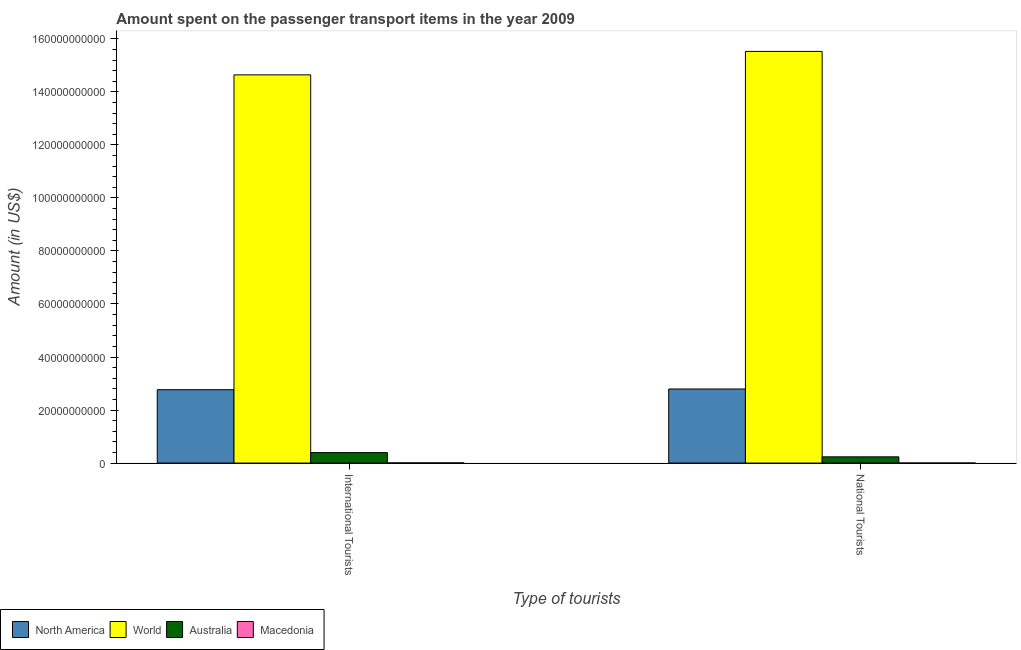How many groups of bars are there?
Your response must be concise. 2. Are the number of bars on each tick of the X-axis equal?
Your answer should be compact. Yes. How many bars are there on the 2nd tick from the left?
Your answer should be compact. 4. How many bars are there on the 2nd tick from the right?
Ensure brevity in your answer.  4. What is the label of the 1st group of bars from the left?
Offer a terse response. International Tourists. What is the amount spent on transport items of national tourists in Australia?
Make the answer very short. 2.34e+09. Across all countries, what is the maximum amount spent on transport items of national tourists?
Give a very brief answer. 1.55e+11. Across all countries, what is the minimum amount spent on transport items of international tourists?
Provide a short and direct response. 5.00e+07. In which country was the amount spent on transport items of international tourists maximum?
Your answer should be compact. World. In which country was the amount spent on transport items of national tourists minimum?
Your answer should be very brief. Macedonia. What is the total amount spent on transport items of international tourists in the graph?
Offer a very short reply. 1.78e+11. What is the difference between the amount spent on transport items of national tourists in World and that in Australia?
Your answer should be compact. 1.53e+11. What is the difference between the amount spent on transport items of international tourists in North America and the amount spent on transport items of national tourists in Macedonia?
Offer a terse response. 2.77e+1. What is the average amount spent on transport items of international tourists per country?
Your answer should be compact. 4.45e+1. What is the difference between the amount spent on transport items of international tourists and amount spent on transport items of national tourists in North America?
Your answer should be very brief. -2.67e+08. What is the ratio of the amount spent on transport items of international tourists in Australia to that in North America?
Offer a terse response. 0.14. In how many countries, is the amount spent on transport items of international tourists greater than the average amount spent on transport items of international tourists taken over all countries?
Provide a succinct answer. 1. What does the 2nd bar from the left in National Tourists represents?
Provide a short and direct response. World. What does the 1st bar from the right in International Tourists represents?
Your answer should be very brief. Macedonia. How many countries are there in the graph?
Give a very brief answer. 4. Does the graph contain any zero values?
Your answer should be very brief. No. Does the graph contain grids?
Offer a very short reply. No. Where does the legend appear in the graph?
Offer a very short reply. Bottom left. How many legend labels are there?
Offer a terse response. 4. How are the legend labels stacked?
Offer a terse response. Horizontal. What is the title of the graph?
Your answer should be compact. Amount spent on the passenger transport items in the year 2009. What is the label or title of the X-axis?
Your answer should be compact. Type of tourists. What is the label or title of the Y-axis?
Make the answer very short. Amount (in US$). What is the Amount (in US$) in North America in International Tourists?
Your answer should be very brief. 2.77e+1. What is the Amount (in US$) in World in International Tourists?
Offer a very short reply. 1.46e+11. What is the Amount (in US$) of Australia in International Tourists?
Your answer should be compact. 3.94e+09. What is the Amount (in US$) in Macedonia in International Tourists?
Ensure brevity in your answer.  5.00e+07. What is the Amount (in US$) in North America in National Tourists?
Your answer should be compact. 2.79e+1. What is the Amount (in US$) of World in National Tourists?
Give a very brief answer. 1.55e+11. What is the Amount (in US$) in Australia in National Tourists?
Make the answer very short. 2.34e+09. What is the Amount (in US$) of Macedonia in National Tourists?
Ensure brevity in your answer.  1.40e+07. Across all Type of tourists, what is the maximum Amount (in US$) of North America?
Your answer should be compact. 2.79e+1. Across all Type of tourists, what is the maximum Amount (in US$) in World?
Offer a very short reply. 1.55e+11. Across all Type of tourists, what is the maximum Amount (in US$) in Australia?
Offer a very short reply. 3.94e+09. Across all Type of tourists, what is the minimum Amount (in US$) of North America?
Offer a terse response. 2.77e+1. Across all Type of tourists, what is the minimum Amount (in US$) of World?
Your response must be concise. 1.46e+11. Across all Type of tourists, what is the minimum Amount (in US$) of Australia?
Your answer should be very brief. 2.34e+09. Across all Type of tourists, what is the minimum Amount (in US$) of Macedonia?
Make the answer very short. 1.40e+07. What is the total Amount (in US$) of North America in the graph?
Provide a short and direct response. 5.56e+1. What is the total Amount (in US$) in World in the graph?
Offer a very short reply. 3.02e+11. What is the total Amount (in US$) in Australia in the graph?
Provide a short and direct response. 6.28e+09. What is the total Amount (in US$) of Macedonia in the graph?
Offer a very short reply. 6.40e+07. What is the difference between the Amount (in US$) in North America in International Tourists and that in National Tourists?
Give a very brief answer. -2.67e+08. What is the difference between the Amount (in US$) of World in International Tourists and that in National Tourists?
Your answer should be very brief. -8.85e+09. What is the difference between the Amount (in US$) in Australia in International Tourists and that in National Tourists?
Your answer should be very brief. 1.60e+09. What is the difference between the Amount (in US$) of Macedonia in International Tourists and that in National Tourists?
Provide a succinct answer. 3.60e+07. What is the difference between the Amount (in US$) of North America in International Tourists and the Amount (in US$) of World in National Tourists?
Your answer should be compact. -1.28e+11. What is the difference between the Amount (in US$) in North America in International Tourists and the Amount (in US$) in Australia in National Tourists?
Ensure brevity in your answer.  2.53e+1. What is the difference between the Amount (in US$) of North America in International Tourists and the Amount (in US$) of Macedonia in National Tourists?
Keep it short and to the point. 2.77e+1. What is the difference between the Amount (in US$) in World in International Tourists and the Amount (in US$) in Australia in National Tourists?
Ensure brevity in your answer.  1.44e+11. What is the difference between the Amount (in US$) of World in International Tourists and the Amount (in US$) of Macedonia in National Tourists?
Offer a terse response. 1.46e+11. What is the difference between the Amount (in US$) in Australia in International Tourists and the Amount (in US$) in Macedonia in National Tourists?
Ensure brevity in your answer.  3.93e+09. What is the average Amount (in US$) in North America per Type of tourists?
Ensure brevity in your answer.  2.78e+1. What is the average Amount (in US$) in World per Type of tourists?
Your answer should be compact. 1.51e+11. What is the average Amount (in US$) in Australia per Type of tourists?
Your answer should be compact. 3.14e+09. What is the average Amount (in US$) of Macedonia per Type of tourists?
Offer a very short reply. 3.20e+07. What is the difference between the Amount (in US$) in North America and Amount (in US$) in World in International Tourists?
Provide a short and direct response. -1.19e+11. What is the difference between the Amount (in US$) of North America and Amount (in US$) of Australia in International Tourists?
Your answer should be very brief. 2.37e+1. What is the difference between the Amount (in US$) of North America and Amount (in US$) of Macedonia in International Tourists?
Offer a very short reply. 2.76e+1. What is the difference between the Amount (in US$) in World and Amount (in US$) in Australia in International Tourists?
Your answer should be very brief. 1.42e+11. What is the difference between the Amount (in US$) of World and Amount (in US$) of Macedonia in International Tourists?
Your answer should be very brief. 1.46e+11. What is the difference between the Amount (in US$) in Australia and Amount (in US$) in Macedonia in International Tourists?
Ensure brevity in your answer.  3.89e+09. What is the difference between the Amount (in US$) in North America and Amount (in US$) in World in National Tourists?
Your answer should be compact. -1.27e+11. What is the difference between the Amount (in US$) in North America and Amount (in US$) in Australia in National Tourists?
Provide a short and direct response. 2.56e+1. What is the difference between the Amount (in US$) of North America and Amount (in US$) of Macedonia in National Tourists?
Offer a terse response. 2.79e+1. What is the difference between the Amount (in US$) in World and Amount (in US$) in Australia in National Tourists?
Offer a very short reply. 1.53e+11. What is the difference between the Amount (in US$) in World and Amount (in US$) in Macedonia in National Tourists?
Ensure brevity in your answer.  1.55e+11. What is the difference between the Amount (in US$) in Australia and Amount (in US$) in Macedonia in National Tourists?
Ensure brevity in your answer.  2.33e+09. What is the ratio of the Amount (in US$) in North America in International Tourists to that in National Tourists?
Your answer should be compact. 0.99. What is the ratio of the Amount (in US$) of World in International Tourists to that in National Tourists?
Offer a terse response. 0.94. What is the ratio of the Amount (in US$) of Australia in International Tourists to that in National Tourists?
Offer a very short reply. 1.68. What is the ratio of the Amount (in US$) in Macedonia in International Tourists to that in National Tourists?
Keep it short and to the point. 3.57. What is the difference between the highest and the second highest Amount (in US$) in North America?
Offer a very short reply. 2.67e+08. What is the difference between the highest and the second highest Amount (in US$) in World?
Give a very brief answer. 8.85e+09. What is the difference between the highest and the second highest Amount (in US$) in Australia?
Give a very brief answer. 1.60e+09. What is the difference between the highest and the second highest Amount (in US$) in Macedonia?
Offer a terse response. 3.60e+07. What is the difference between the highest and the lowest Amount (in US$) in North America?
Offer a terse response. 2.67e+08. What is the difference between the highest and the lowest Amount (in US$) of World?
Your answer should be compact. 8.85e+09. What is the difference between the highest and the lowest Amount (in US$) of Australia?
Offer a very short reply. 1.60e+09. What is the difference between the highest and the lowest Amount (in US$) in Macedonia?
Make the answer very short. 3.60e+07. 